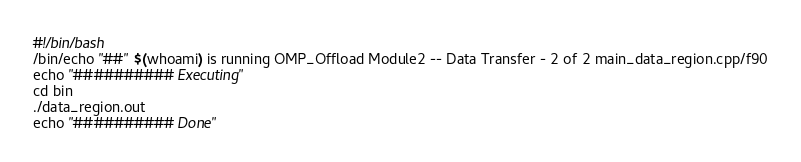<code> <loc_0><loc_0><loc_500><loc_500><_Bash_>#!/bin/bash
/bin/echo "##" $(whoami) is running OMP_Offload Module2 -- Data Transfer - 2 of 2 main_data_region.cpp/f90
echo "########## Executing"
cd bin
./data_region.out
echo "########## Done"
</code> 